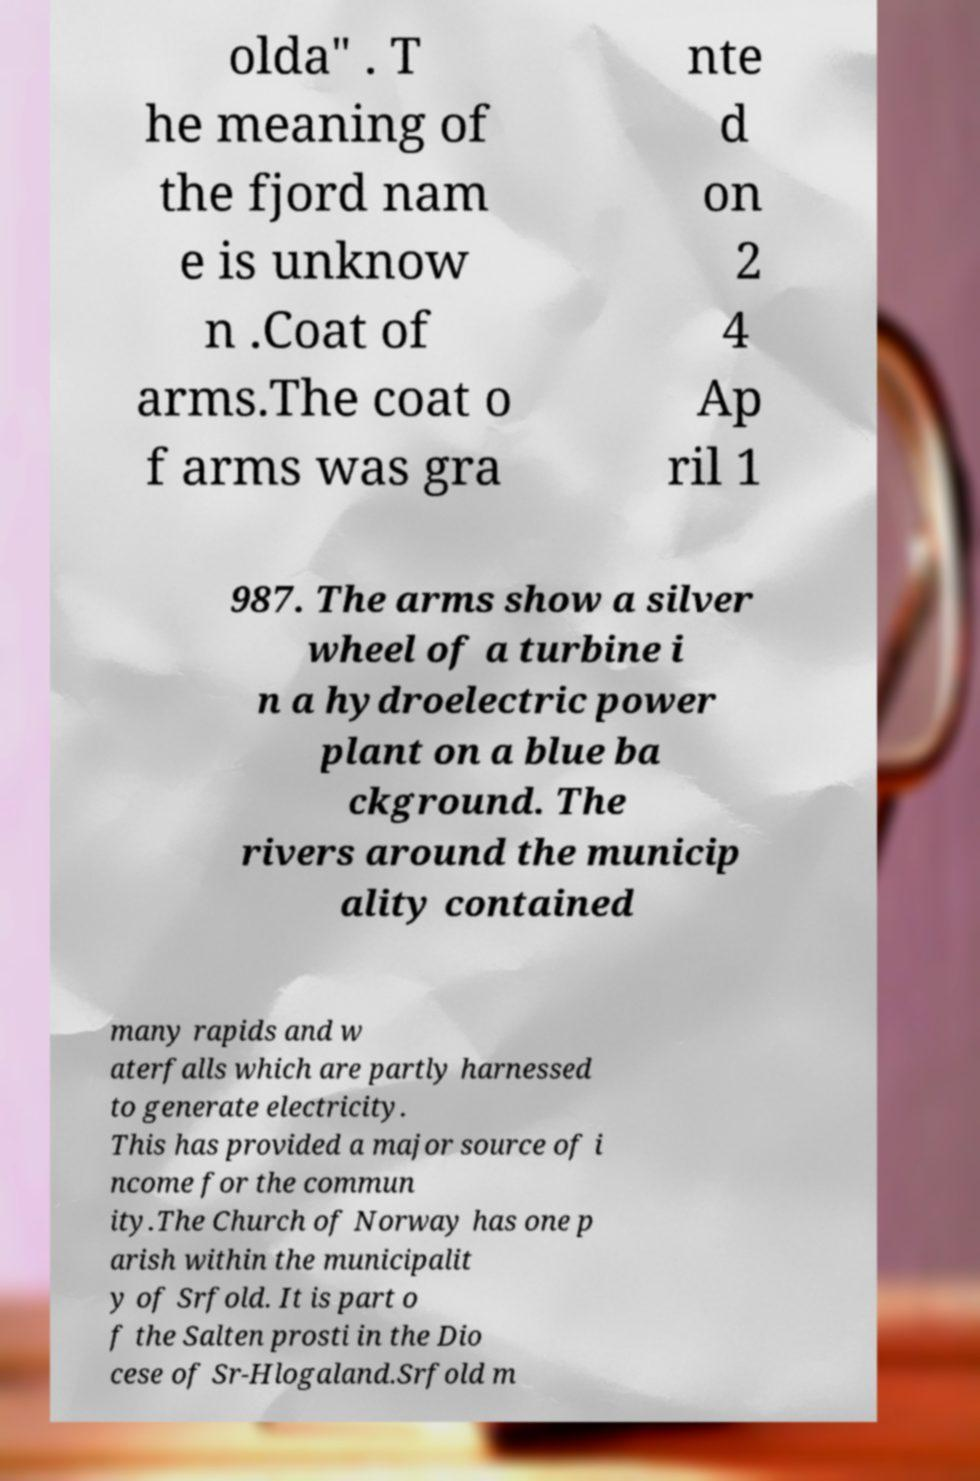There's text embedded in this image that I need extracted. Can you transcribe it verbatim? olda" . T he meaning of the fjord nam e is unknow n .Coat of arms.The coat o f arms was gra nte d on 2 4 Ap ril 1 987. The arms show a silver wheel of a turbine i n a hydroelectric power plant on a blue ba ckground. The rivers around the municip ality contained many rapids and w aterfalls which are partly harnessed to generate electricity. This has provided a major source of i ncome for the commun ity.The Church of Norway has one p arish within the municipalit y of Srfold. It is part o f the Salten prosti in the Dio cese of Sr-Hlogaland.Srfold m 